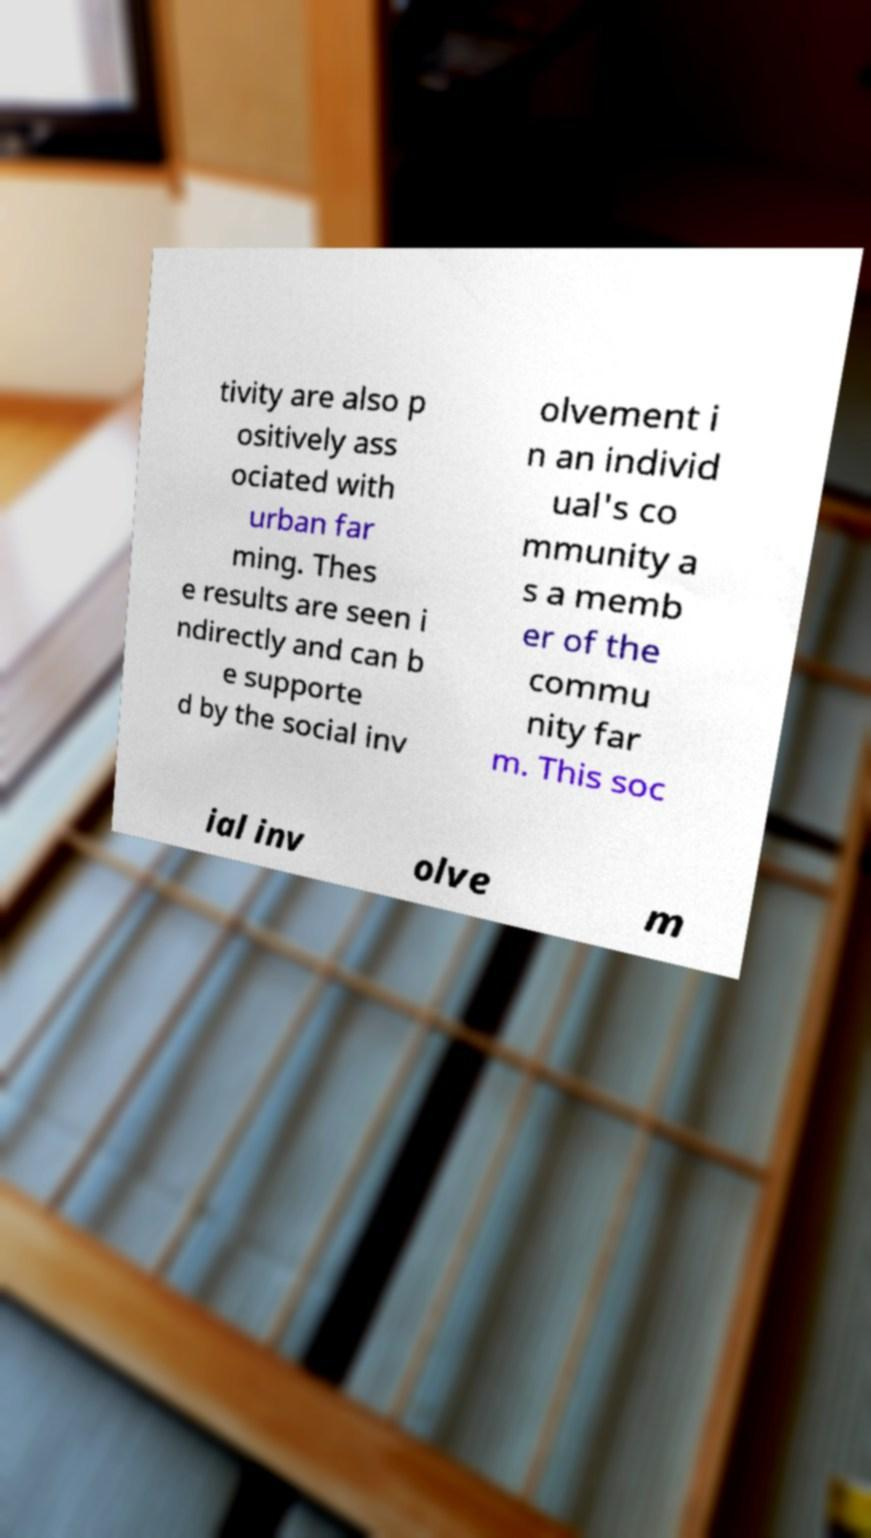Can you accurately transcribe the text from the provided image for me? tivity are also p ositively ass ociated with urban far ming. Thes e results are seen i ndirectly and can b e supporte d by the social inv olvement i n an individ ual's co mmunity a s a memb er of the commu nity far m. This soc ial inv olve m 